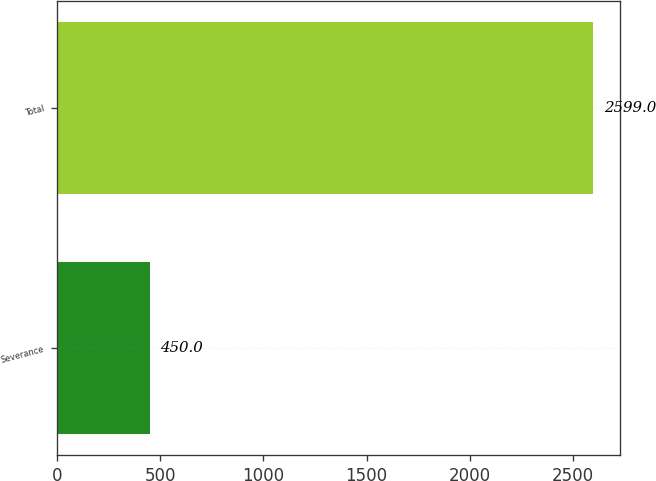Convert chart. <chart><loc_0><loc_0><loc_500><loc_500><bar_chart><fcel>Severance<fcel>Total<nl><fcel>450<fcel>2599<nl></chart> 